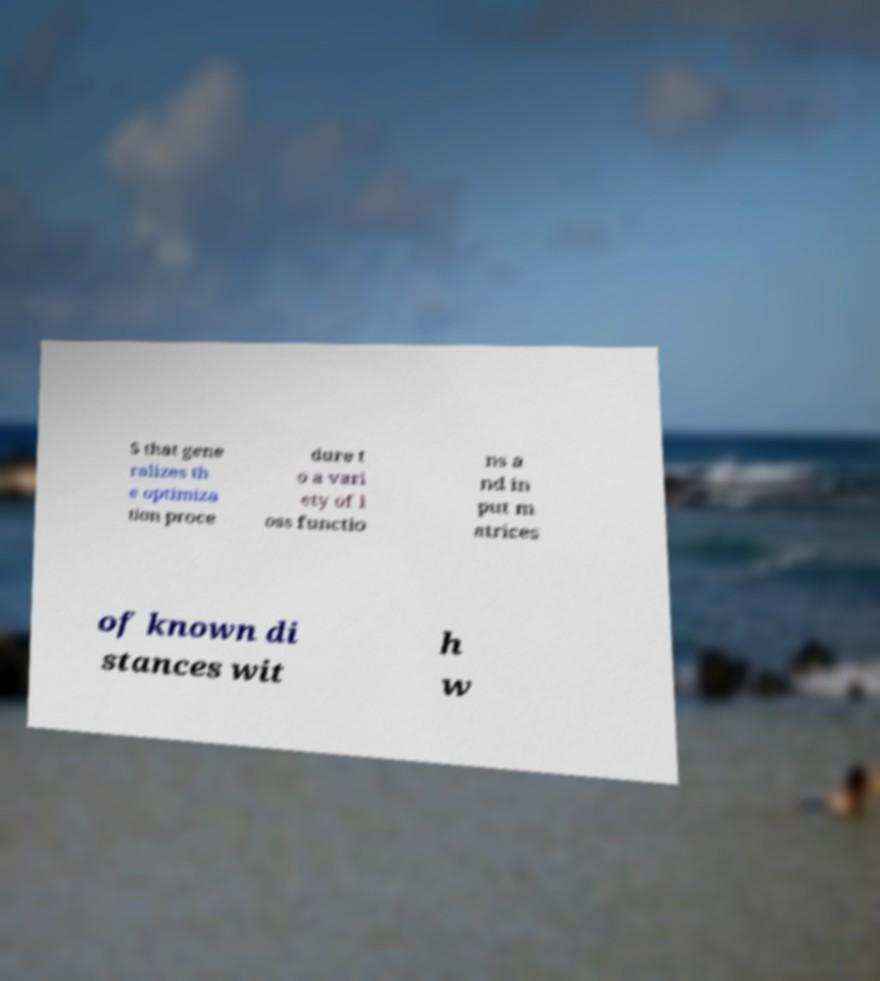What messages or text are displayed in this image? I need them in a readable, typed format. S that gene ralizes th e optimiza tion proce dure t o a vari ety of l oss functio ns a nd in put m atrices of known di stances wit h w 